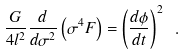Convert formula to latex. <formula><loc_0><loc_0><loc_500><loc_500>\frac { G } { 4 l ^ { 2 } } \frac { d } { d \sigma ^ { 2 } } \left ( \sigma ^ { 4 } F \right ) = \left ( \frac { d \phi } { d t } \right ) ^ { 2 } \ .</formula> 